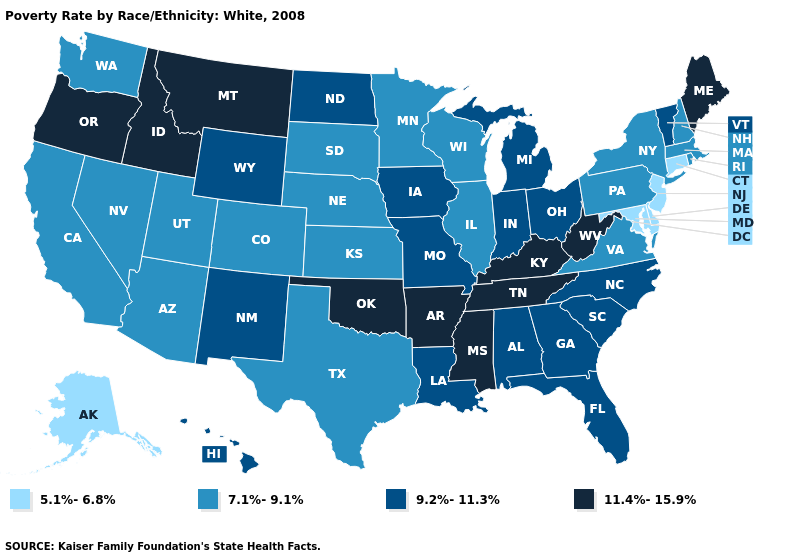What is the value of Connecticut?
Short answer required. 5.1%-6.8%. Name the states that have a value in the range 11.4%-15.9%?
Quick response, please. Arkansas, Idaho, Kentucky, Maine, Mississippi, Montana, Oklahoma, Oregon, Tennessee, West Virginia. Name the states that have a value in the range 9.2%-11.3%?
Be succinct. Alabama, Florida, Georgia, Hawaii, Indiana, Iowa, Louisiana, Michigan, Missouri, New Mexico, North Carolina, North Dakota, Ohio, South Carolina, Vermont, Wyoming. Does Massachusetts have the highest value in the Northeast?
Answer briefly. No. Is the legend a continuous bar?
Write a very short answer. No. How many symbols are there in the legend?
Quick response, please. 4. What is the lowest value in the USA?
Concise answer only. 5.1%-6.8%. What is the lowest value in the USA?
Answer briefly. 5.1%-6.8%. What is the value of Iowa?
Answer briefly. 9.2%-11.3%. What is the value of Maine?
Answer briefly. 11.4%-15.9%. Name the states that have a value in the range 11.4%-15.9%?
Short answer required. Arkansas, Idaho, Kentucky, Maine, Mississippi, Montana, Oklahoma, Oregon, Tennessee, West Virginia. What is the value of North Carolina?
Concise answer only. 9.2%-11.3%. Which states have the lowest value in the USA?
Quick response, please. Alaska, Connecticut, Delaware, Maryland, New Jersey. What is the value of North Dakota?
Be succinct. 9.2%-11.3%. 